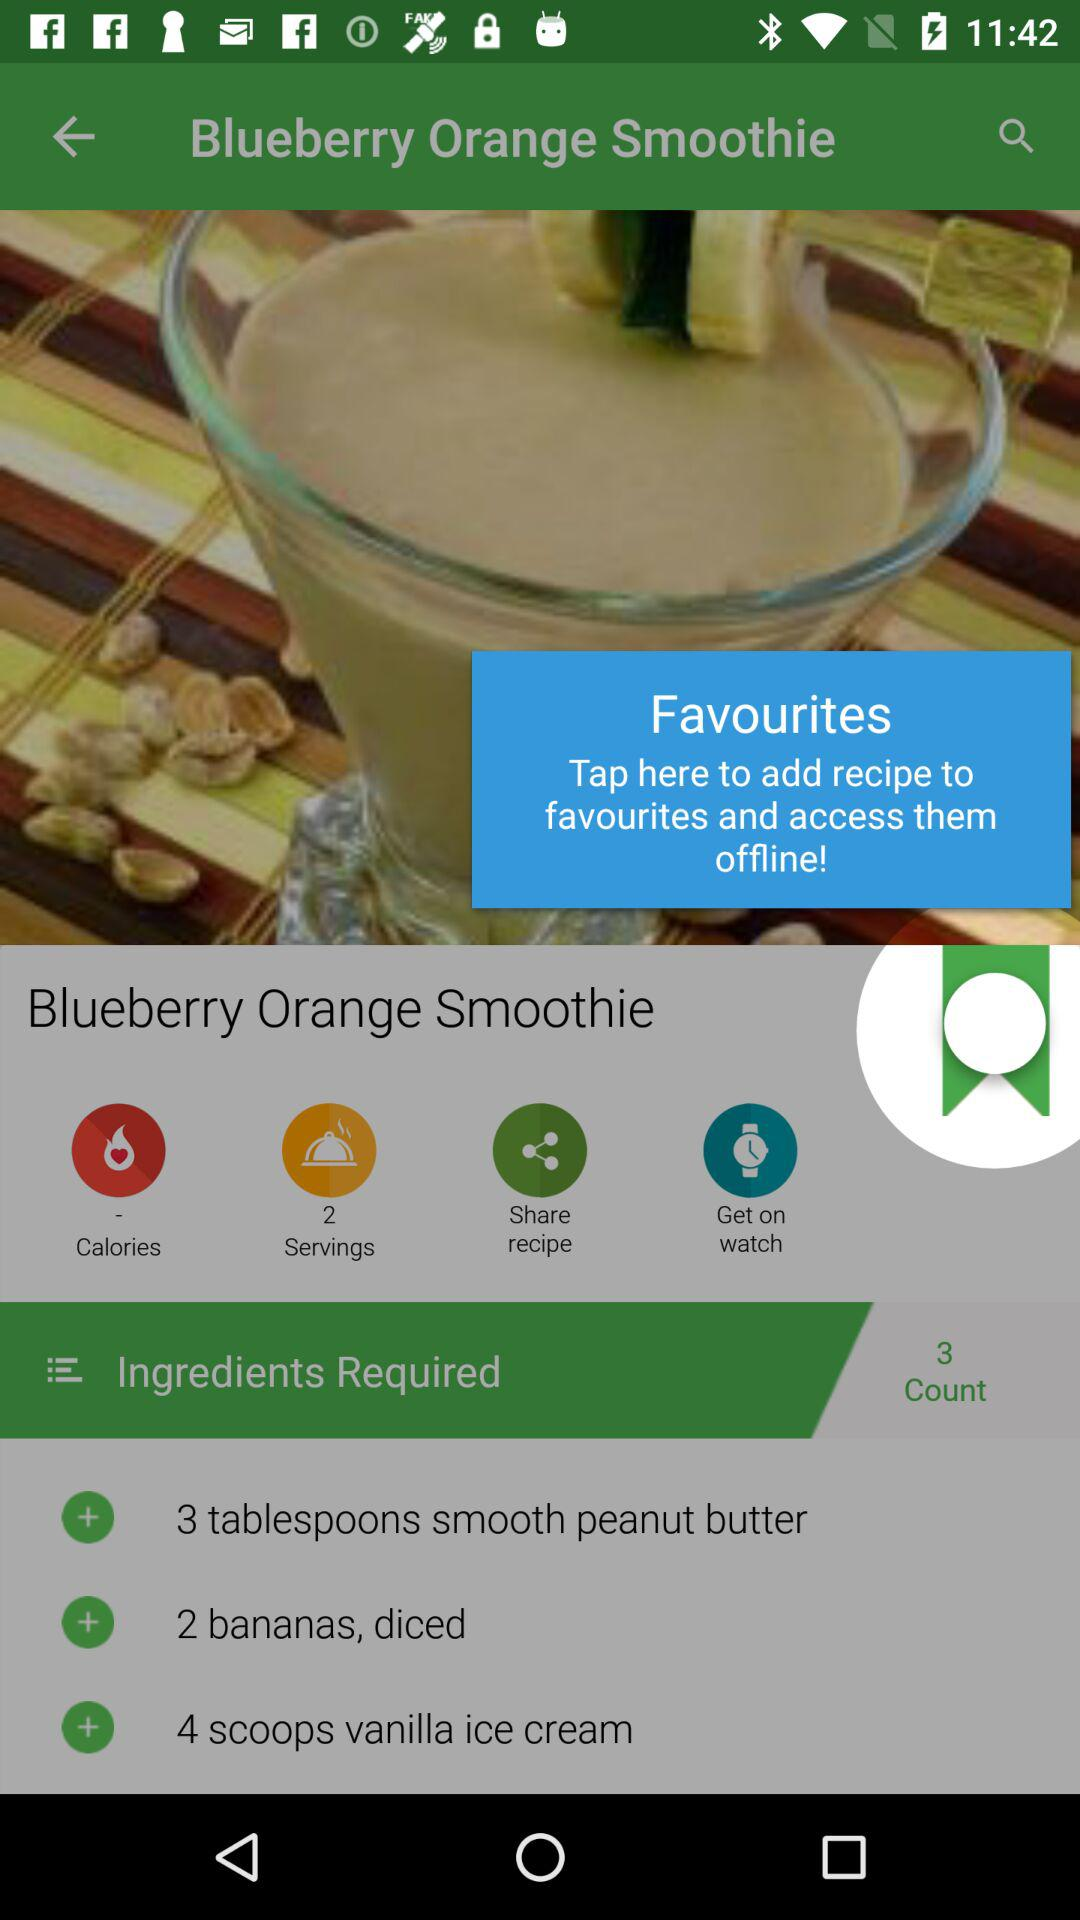What is the name of the dish? The name of the dish is "Blueberry Orange Smoothie". 